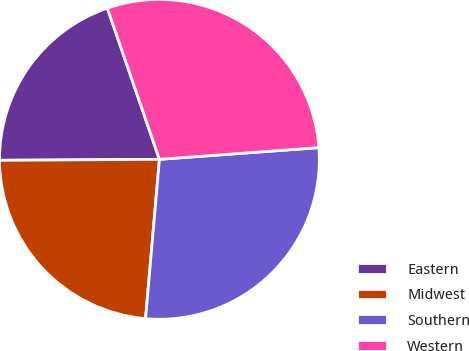<chart> <loc_0><loc_0><loc_500><loc_500><pie_chart><fcel>Eastern<fcel>Midwest<fcel>Southern<fcel>Western<nl><fcel>19.82%<fcel>23.52%<fcel>27.55%<fcel>29.11%<nl></chart> 